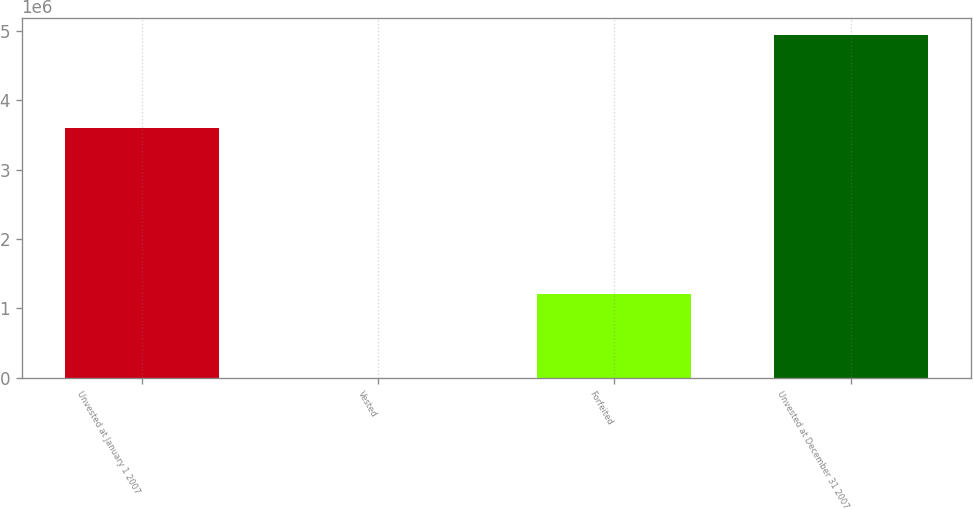Convert chart. <chart><loc_0><loc_0><loc_500><loc_500><bar_chart><fcel>Unvested at January 1 2007<fcel>Vested<fcel>Forfeited<fcel>Unvested at December 31 2007<nl><fcel>3.60704e+06<fcel>550<fcel>1.21258e+06<fcel>4.94152e+06<nl></chart> 